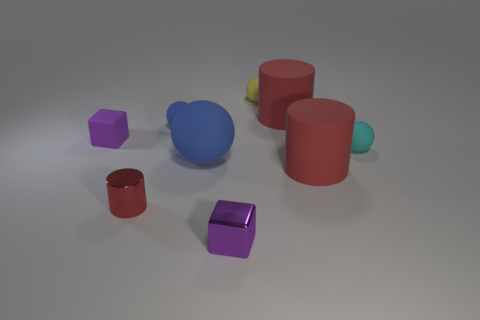Subtract all red cylinders. How many were subtracted if there are1red cylinders left? 2 Subtract all small blue rubber spheres. How many spheres are left? 3 Add 3 tiny matte blocks. How many tiny matte blocks are left? 4 Add 6 yellow objects. How many yellow objects exist? 7 Add 1 red metallic things. How many objects exist? 10 Subtract all cyan balls. How many balls are left? 3 Subtract 1 blue balls. How many objects are left? 8 Subtract all balls. How many objects are left? 5 Subtract 3 spheres. How many spheres are left? 1 Subtract all brown cylinders. Subtract all purple blocks. How many cylinders are left? 3 